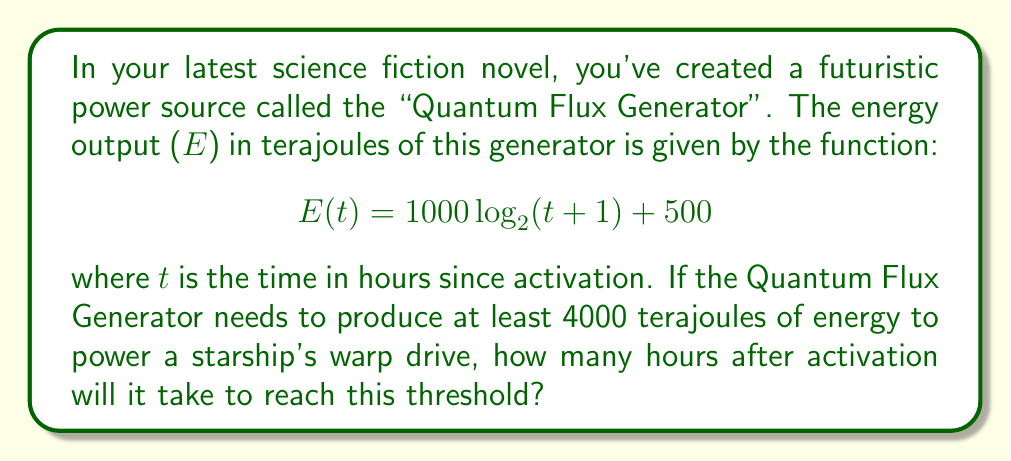Can you solve this math problem? To solve this problem, we need to use the given logarithmic function and solve for t when E(t) = 4000. Let's approach this step-by-step:

1) We start with the equation:
   $$ 4000 = 1000 \log_2(t + 1) + 500 $$

2) Subtract 500 from both sides:
   $$ 3500 = 1000 \log_2(t + 1) $$

3) Divide both sides by 1000:
   $$ 3.5 = \log_2(t + 1) $$

4) To solve for t, we need to apply the inverse function of $\log_2$, which is $2^x$:
   $$ 2^{3.5} = t + 1 $$

5) Calculate $2^{3.5}$:
   $$ 2^{3.5} \approx 11.3137 $$

6) Subtract 1 from both sides to isolate t:
   $$ t \approx 10.3137 $$

7) Since time must be a whole number of hours in this context, we round up to the next integer.

Therefore, it will take 11 hours after activation for the Quantum Flux Generator to produce at least 4000 terajoules of energy.
Answer: 11 hours 